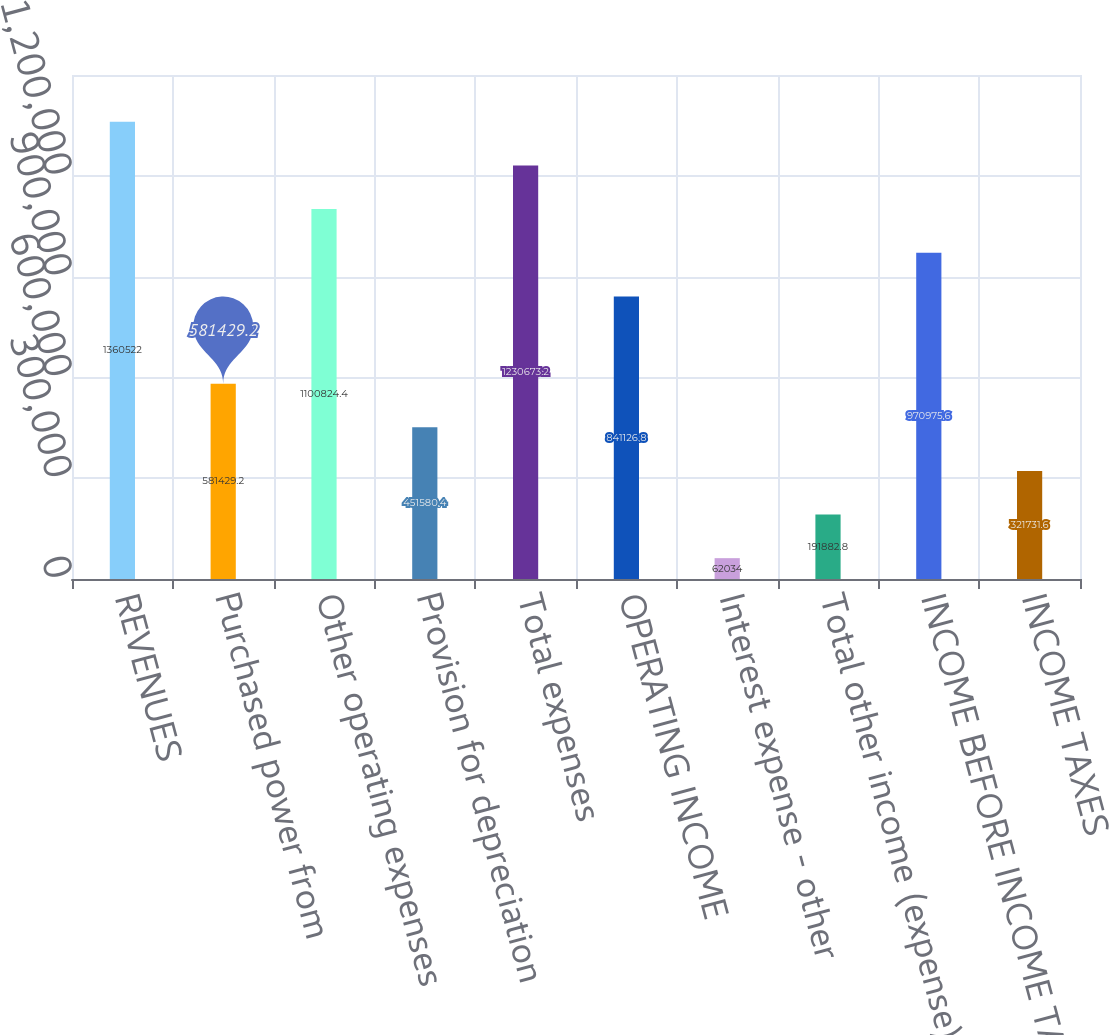Convert chart to OTSL. <chart><loc_0><loc_0><loc_500><loc_500><bar_chart><fcel>REVENUES<fcel>Purchased power from<fcel>Other operating expenses<fcel>Provision for depreciation<fcel>Total expenses<fcel>OPERATING INCOME<fcel>Interest expense - other<fcel>Total other income (expense)<fcel>INCOME BEFORE INCOME TAXES<fcel>INCOME TAXES<nl><fcel>1.36052e+06<fcel>581429<fcel>1.10082e+06<fcel>451580<fcel>1.23067e+06<fcel>841127<fcel>62034<fcel>191883<fcel>970976<fcel>321732<nl></chart> 